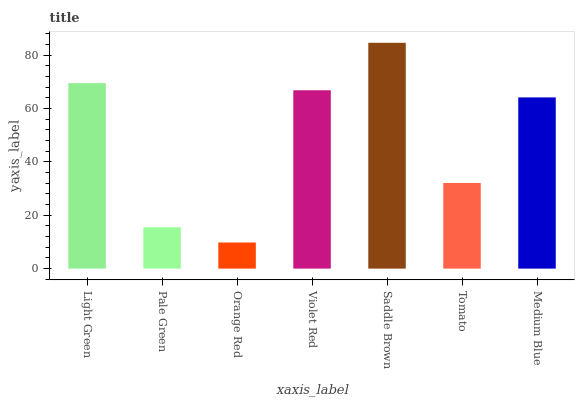Is Orange Red the minimum?
Answer yes or no. Yes. Is Saddle Brown the maximum?
Answer yes or no. Yes. Is Pale Green the minimum?
Answer yes or no. No. Is Pale Green the maximum?
Answer yes or no. No. Is Light Green greater than Pale Green?
Answer yes or no. Yes. Is Pale Green less than Light Green?
Answer yes or no. Yes. Is Pale Green greater than Light Green?
Answer yes or no. No. Is Light Green less than Pale Green?
Answer yes or no. No. Is Medium Blue the high median?
Answer yes or no. Yes. Is Medium Blue the low median?
Answer yes or no. Yes. Is Light Green the high median?
Answer yes or no. No. Is Saddle Brown the low median?
Answer yes or no. No. 